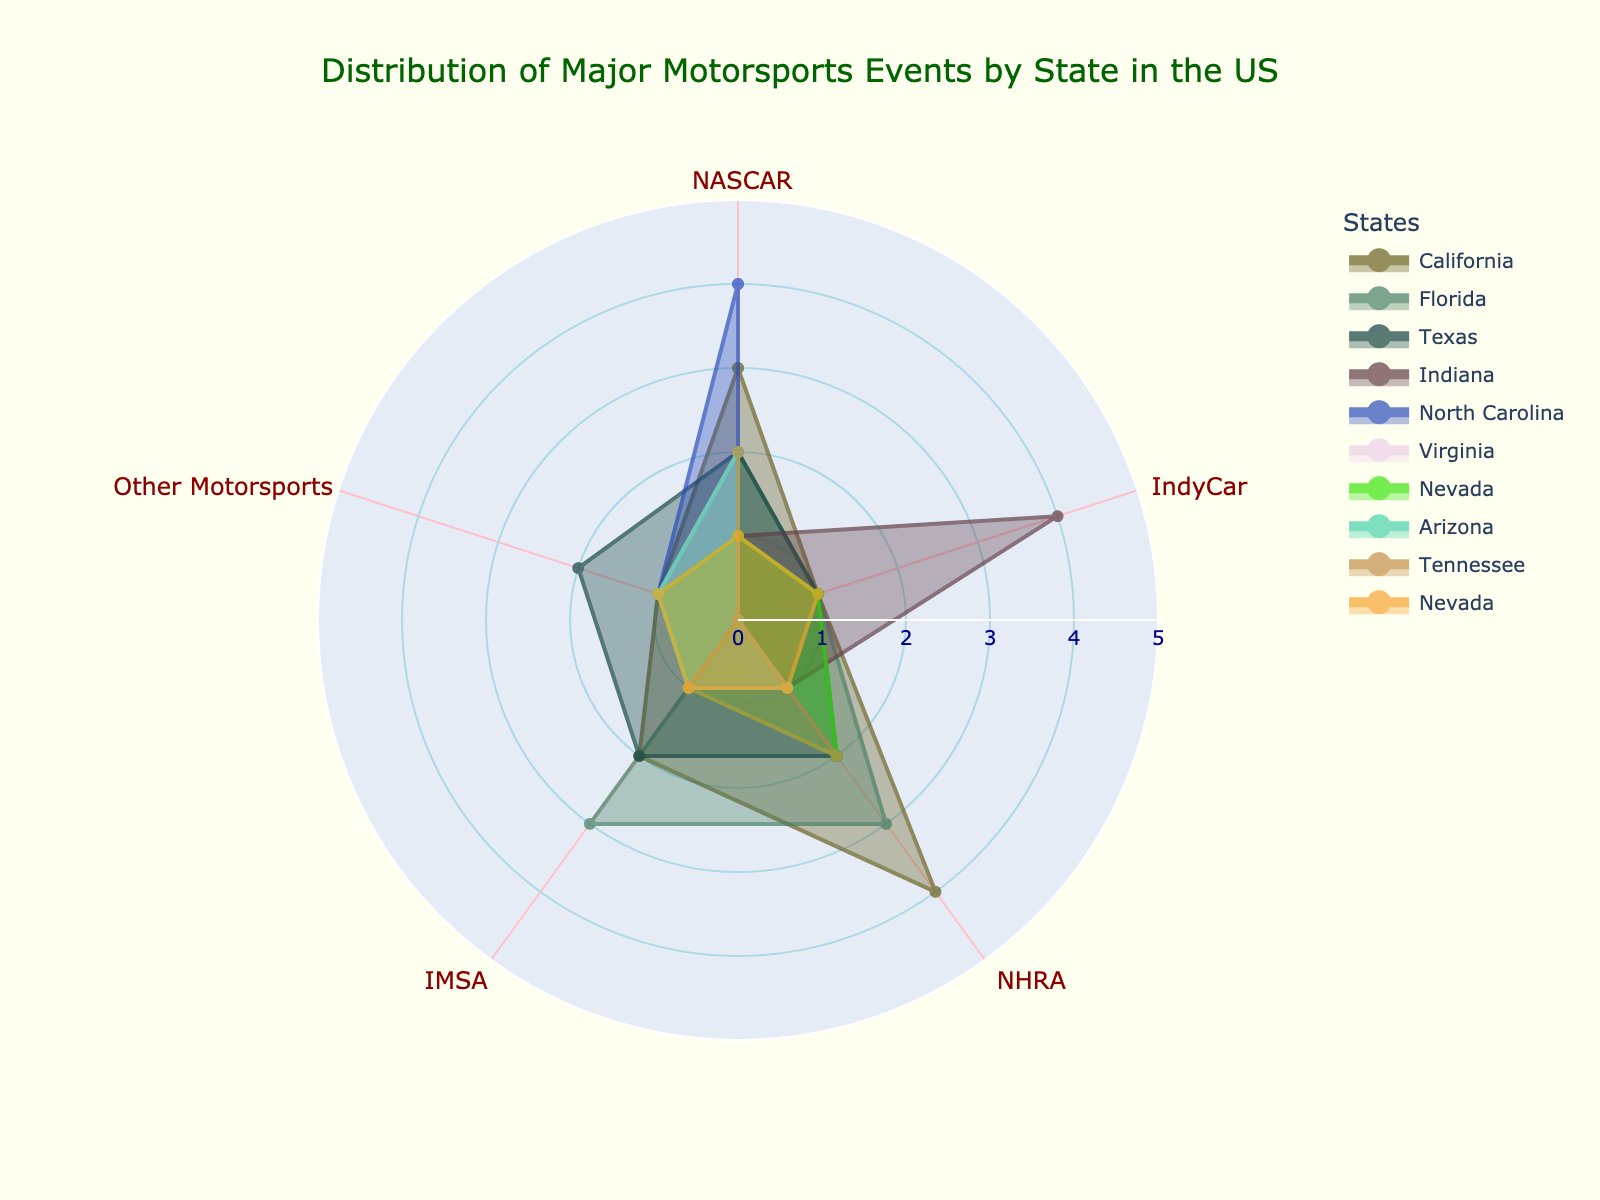What's the title of the chart? The title is prominently displayed at the top of the chart. It reads, "Distribution of Major Motorsports Events by State in the US."
Answer: Distribution of Major Motorsports Events by State in the US Which state has the highest number of NASCAR events? Looking at the plot, the state with the largest radial extend in the NASCAR category is North Carolina.
Answer: North Carolina In which state are the IndyCar events concentrated the most? The category with the longest radius in IndyCar is for Indiana, indicating the highest concentration of IndyCar events there.
Answer: Indiana How many states have at least 3 events in NASCAR? By counting the number of states with the radial length of 3 or more in the NASCAR category, it includes California and North Carolina.
Answer: 2 What is the total number of major motorsports events in Texas? Adding the values for each category in Texas: NASCAR (2) + IndyCar (1) + NHRA (2) + IMSA (2) + Other Motorsports (2) gives a sum of 9.
Answer: 9 Which state has an equal number of events across all motorsport categories? By observing the data, no state has an equal number of events across NASCAR, IndyCar, NHRA, IMSA, and Other Motorsports categories.
Answer: None How does Florida compare to California in terms of IMSA events? In the IMSA category, California has 2 events while Florida has 3 events. Therefore, Florida has 1 more IMSA event than California.
Answer: Florida has 1 more Which state has the least NHRA events? The states with the minimum radial extent for NHRA (1 event) include Virginia, Indiana, Arizona, Nevada (2 states named Nevada with 1 event each).
Answer: Virginia, Indiana, Arizona, Nevada What is the average number of NHRA events across all states? Summing the NHRA events (California: 4, Florida: 3, Texas: 2, Indiana: 1, North Carolina: 2, Virginia: 1, Nevada: 3, Arizona: 1, Tennessee: 2) gives 19 events. Dividing by 9 states provides an average of 19/9 ≈ 2.11 events.
Answer: ~2.11 Which category features all states with at least one event each? On examining the plot for each category: NASCAR, IndyCar, NHRA, IMSA, and Other Motorsports, all states have at least one event in the 'NHRA' category.
Answer: NHRA 